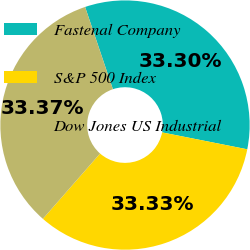<chart> <loc_0><loc_0><loc_500><loc_500><pie_chart><fcel>Fastenal Company<fcel>S&P 500 Index<fcel>Dow Jones US Industrial<nl><fcel>33.3%<fcel>33.33%<fcel>33.37%<nl></chart> 